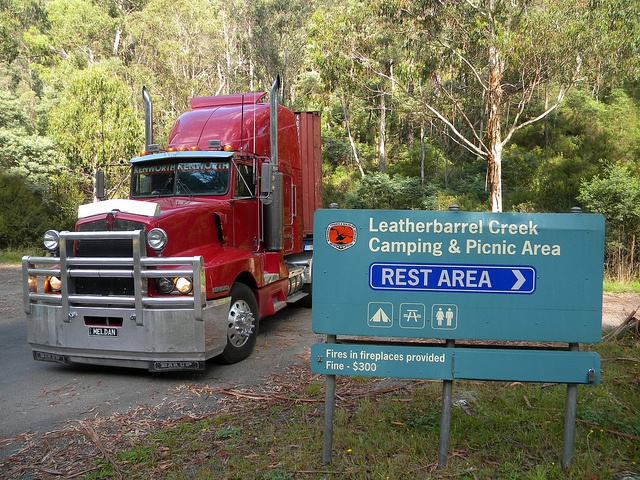Describe the objects in this image and their specific colors. I can see a truck in olive, gray, black, maroon, and brown tones in this image. 